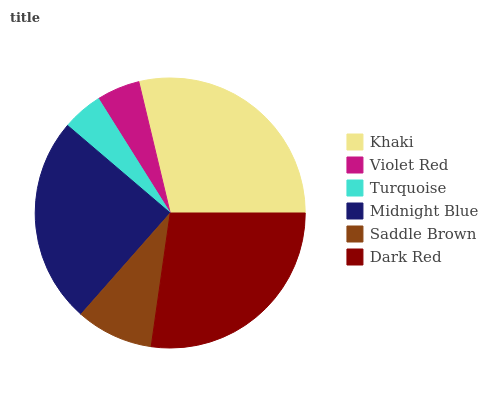Is Turquoise the minimum?
Answer yes or no. Yes. Is Khaki the maximum?
Answer yes or no. Yes. Is Violet Red the minimum?
Answer yes or no. No. Is Violet Red the maximum?
Answer yes or no. No. Is Khaki greater than Violet Red?
Answer yes or no. Yes. Is Violet Red less than Khaki?
Answer yes or no. Yes. Is Violet Red greater than Khaki?
Answer yes or no. No. Is Khaki less than Violet Red?
Answer yes or no. No. Is Midnight Blue the high median?
Answer yes or no. Yes. Is Saddle Brown the low median?
Answer yes or no. Yes. Is Saddle Brown the high median?
Answer yes or no. No. Is Dark Red the low median?
Answer yes or no. No. 